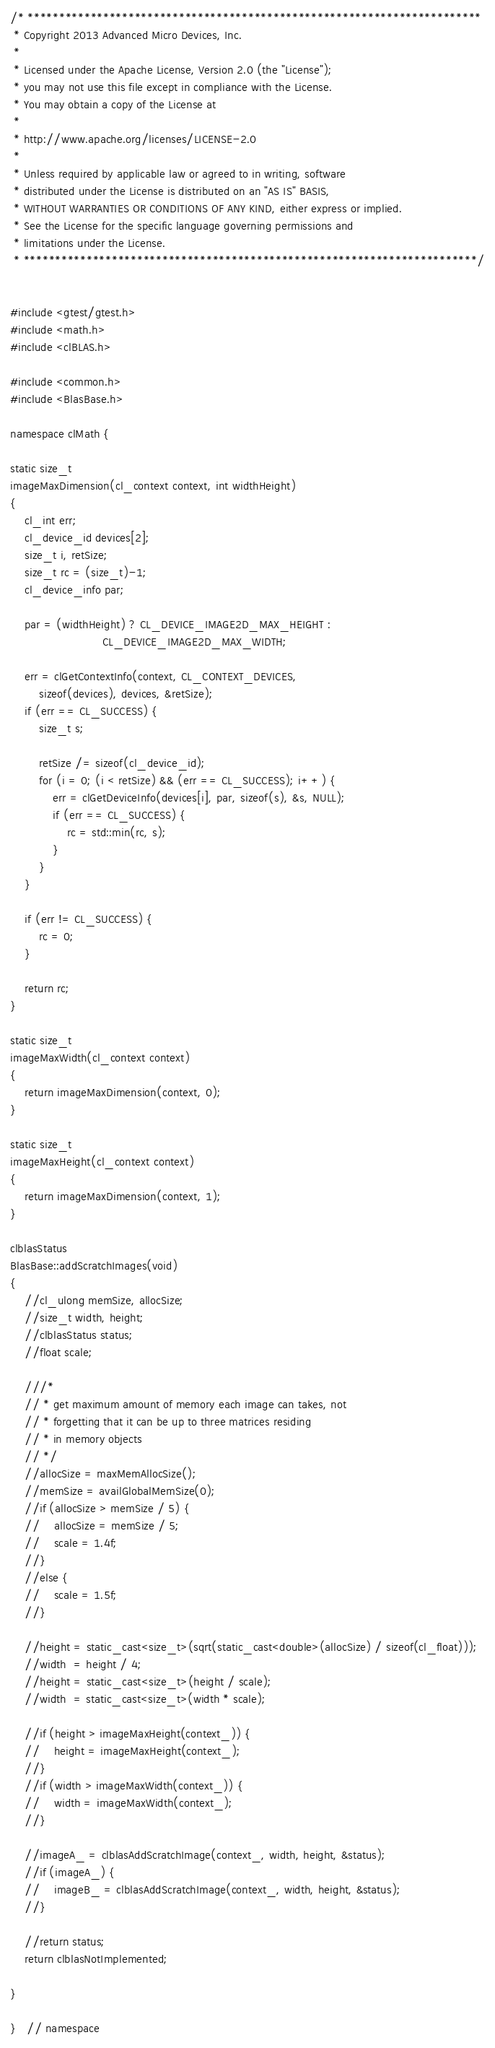<code> <loc_0><loc_0><loc_500><loc_500><_C++_>/* ************************************************************************
 * Copyright 2013 Advanced Micro Devices, Inc.
 *
 * Licensed under the Apache License, Version 2.0 (the "License");
 * you may not use this file except in compliance with the License.
 * You may obtain a copy of the License at
 *
 * http://www.apache.org/licenses/LICENSE-2.0
 *
 * Unless required by applicable law or agreed to in writing, software
 * distributed under the License is distributed on an "AS IS" BASIS,
 * WITHOUT WARRANTIES OR CONDITIONS OF ANY KIND, either express or implied.
 * See the License for the specific language governing permissions and
 * limitations under the License.
 * ************************************************************************/


#include <gtest/gtest.h>
#include <math.h>
#include <clBLAS.h>

#include <common.h>
#include <BlasBase.h>

namespace clMath {

static size_t
imageMaxDimension(cl_context context, int widthHeight)
{
    cl_int err;
    cl_device_id devices[2];
    size_t i, retSize;
    size_t rc = (size_t)-1;
    cl_device_info par;

    par = (widthHeight) ? CL_DEVICE_IMAGE2D_MAX_HEIGHT :
                          CL_DEVICE_IMAGE2D_MAX_WIDTH;

    err = clGetContextInfo(context, CL_CONTEXT_DEVICES,
        sizeof(devices), devices, &retSize);
    if (err == CL_SUCCESS) {
        size_t s;

        retSize /= sizeof(cl_device_id);
        for (i = 0; (i < retSize) && (err == CL_SUCCESS); i++) {
            err = clGetDeviceInfo(devices[i], par, sizeof(s), &s, NULL);
            if (err == CL_SUCCESS) {
                rc = std::min(rc, s);
            }
        }
    }

    if (err != CL_SUCCESS) {
        rc = 0;
    }

    return rc;
}

static size_t
imageMaxWidth(cl_context context)
{
    return imageMaxDimension(context, 0);
}

static size_t
imageMaxHeight(cl_context context)
{
    return imageMaxDimension(context, 1);
}

clblasStatus
BlasBase::addScratchImages(void)
{
    //cl_ulong memSize, allocSize;
    //size_t width, height;
    //clblasStatus status;
    //float scale;

    ///*
    // * get maximum amount of memory each image can takes, not
    // * forgetting that it can be up to three matrices residing
    // * in memory objects
    // */
    //allocSize = maxMemAllocSize();
    //memSize = availGlobalMemSize(0);
    //if (allocSize > memSize / 5) {
    //    allocSize = memSize / 5;
    //    scale = 1.4f;
    //}
    //else {
    //    scale = 1.5f;
    //}

    //height = static_cast<size_t>(sqrt(static_cast<double>(allocSize) / sizeof(cl_float)));
    //width  = height / 4;
    //height = static_cast<size_t>(height / scale);
    //width  = static_cast<size_t>(width * scale);

    //if (height > imageMaxHeight(context_)) {
    //    height = imageMaxHeight(context_);
    //}
    //if (width > imageMaxWidth(context_)) {
    //    width = imageMaxWidth(context_);
    //}

    //imageA_ = clblasAddScratchImage(context_, width, height, &status);
    //if (imageA_) {
    //    imageB_ = clblasAddScratchImage(context_, width, height, &status);
    //}

    //return status;
	return clblasNotImplemented;

}

}   // namespace
</code> 